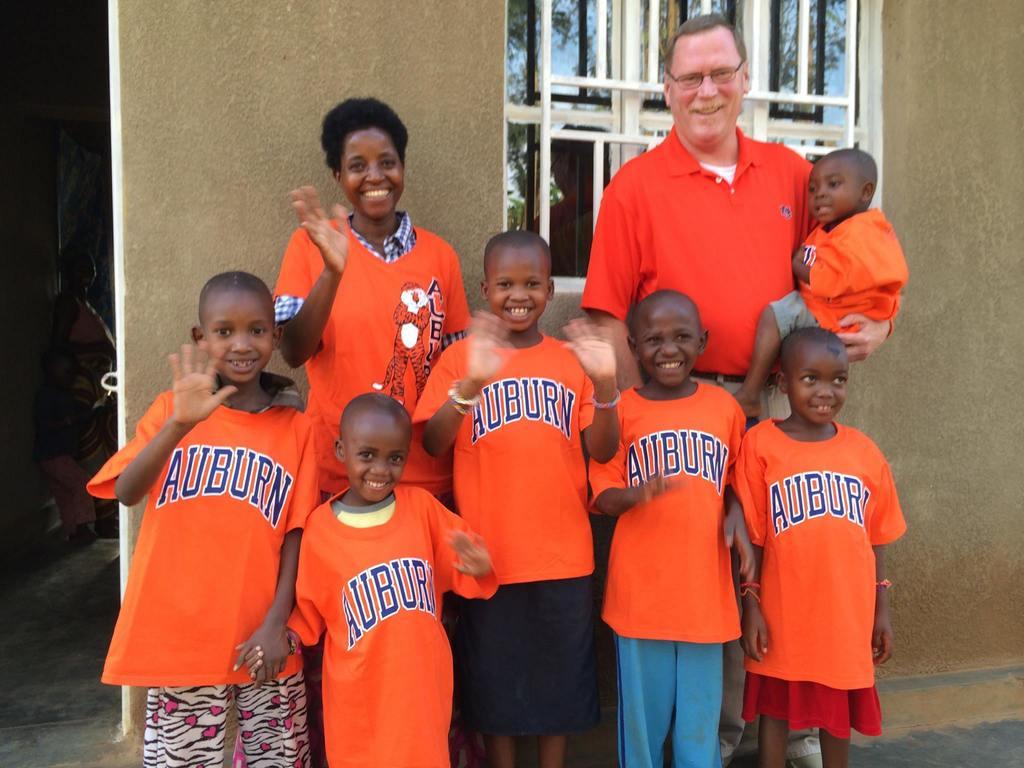What name is on the front of the shirts?
Offer a terse response. Auburn. 